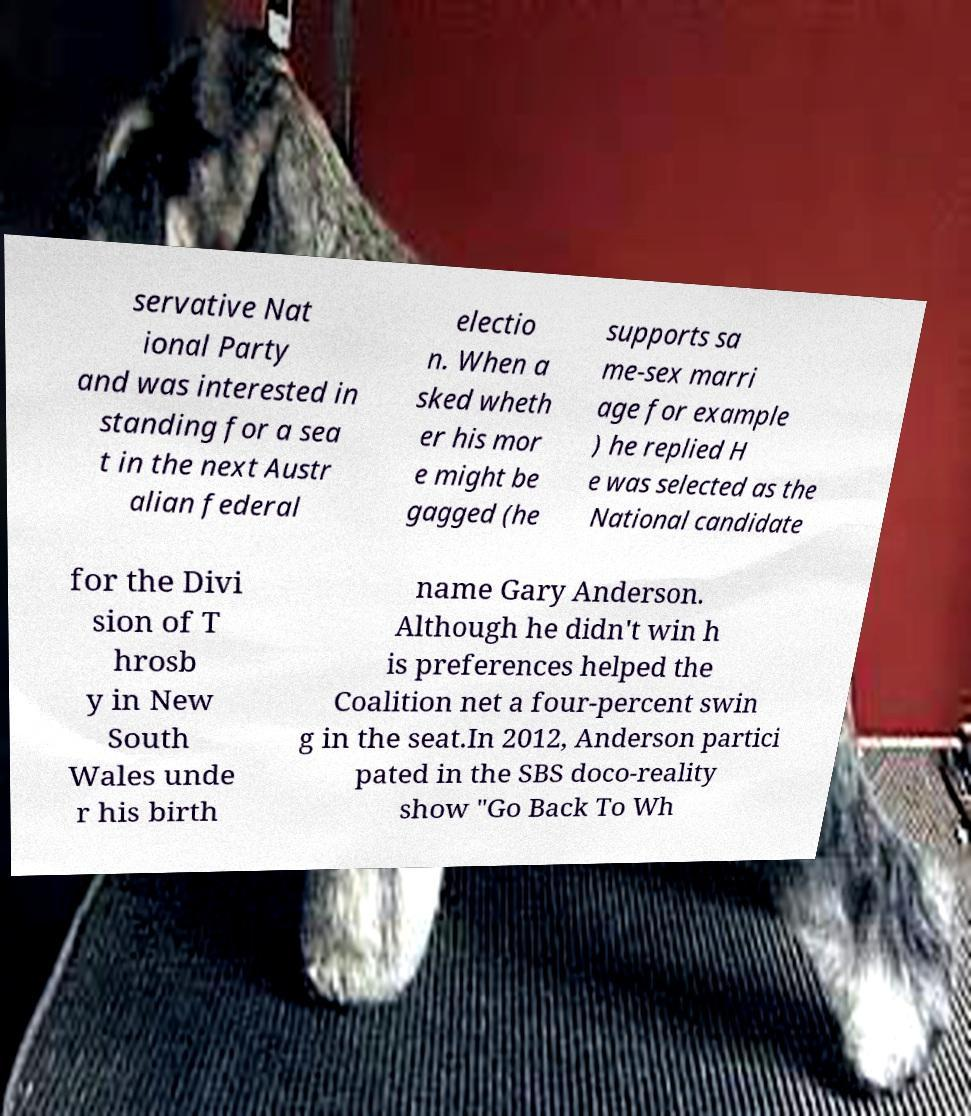Can you accurately transcribe the text from the provided image for me? servative Nat ional Party and was interested in standing for a sea t in the next Austr alian federal electio n. When a sked wheth er his mor e might be gagged (he supports sa me-sex marri age for example ) he replied H e was selected as the National candidate for the Divi sion of T hrosb y in New South Wales unde r his birth name Gary Anderson. Although he didn't win h is preferences helped the Coalition net a four-percent swin g in the seat.In 2012, Anderson partici pated in the SBS doco-reality show "Go Back To Wh 